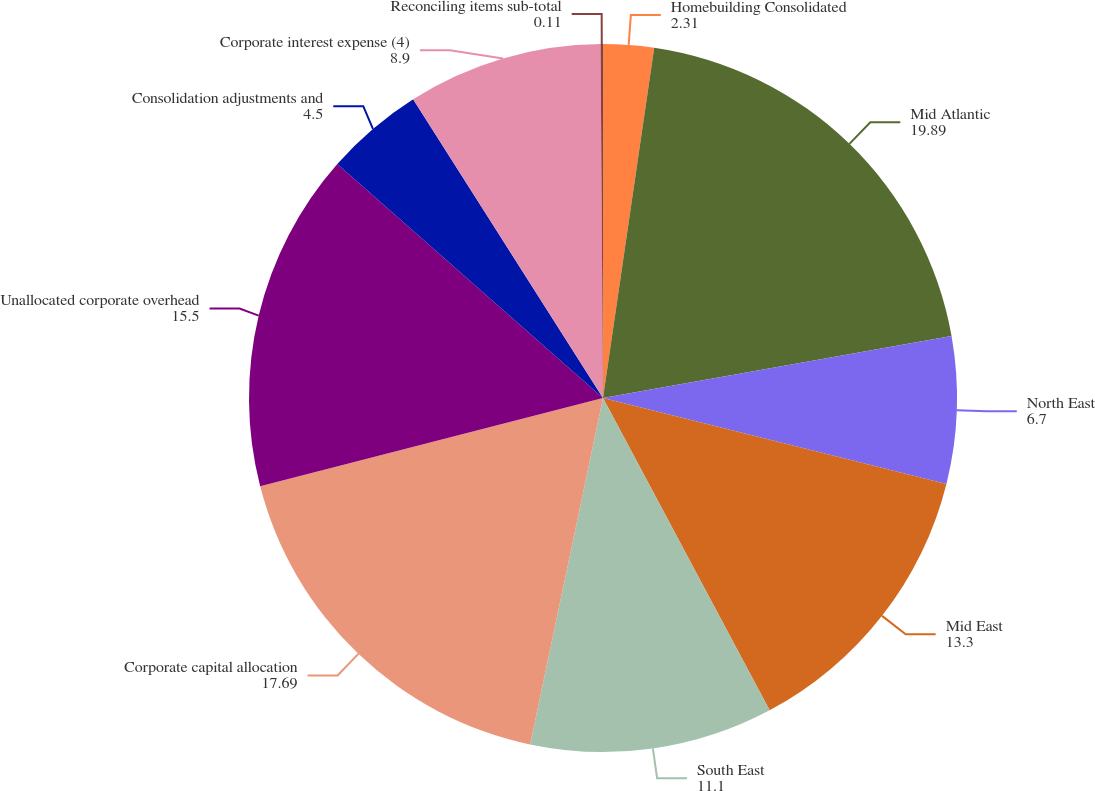Convert chart. <chart><loc_0><loc_0><loc_500><loc_500><pie_chart><fcel>Homebuilding Consolidated<fcel>Mid Atlantic<fcel>North East<fcel>Mid East<fcel>South East<fcel>Corporate capital allocation<fcel>Unallocated corporate overhead<fcel>Consolidation adjustments and<fcel>Corporate interest expense (4)<fcel>Reconciling items sub-total<nl><fcel>2.31%<fcel>19.89%<fcel>6.7%<fcel>13.3%<fcel>11.1%<fcel>17.69%<fcel>15.5%<fcel>4.5%<fcel>8.9%<fcel>0.11%<nl></chart> 